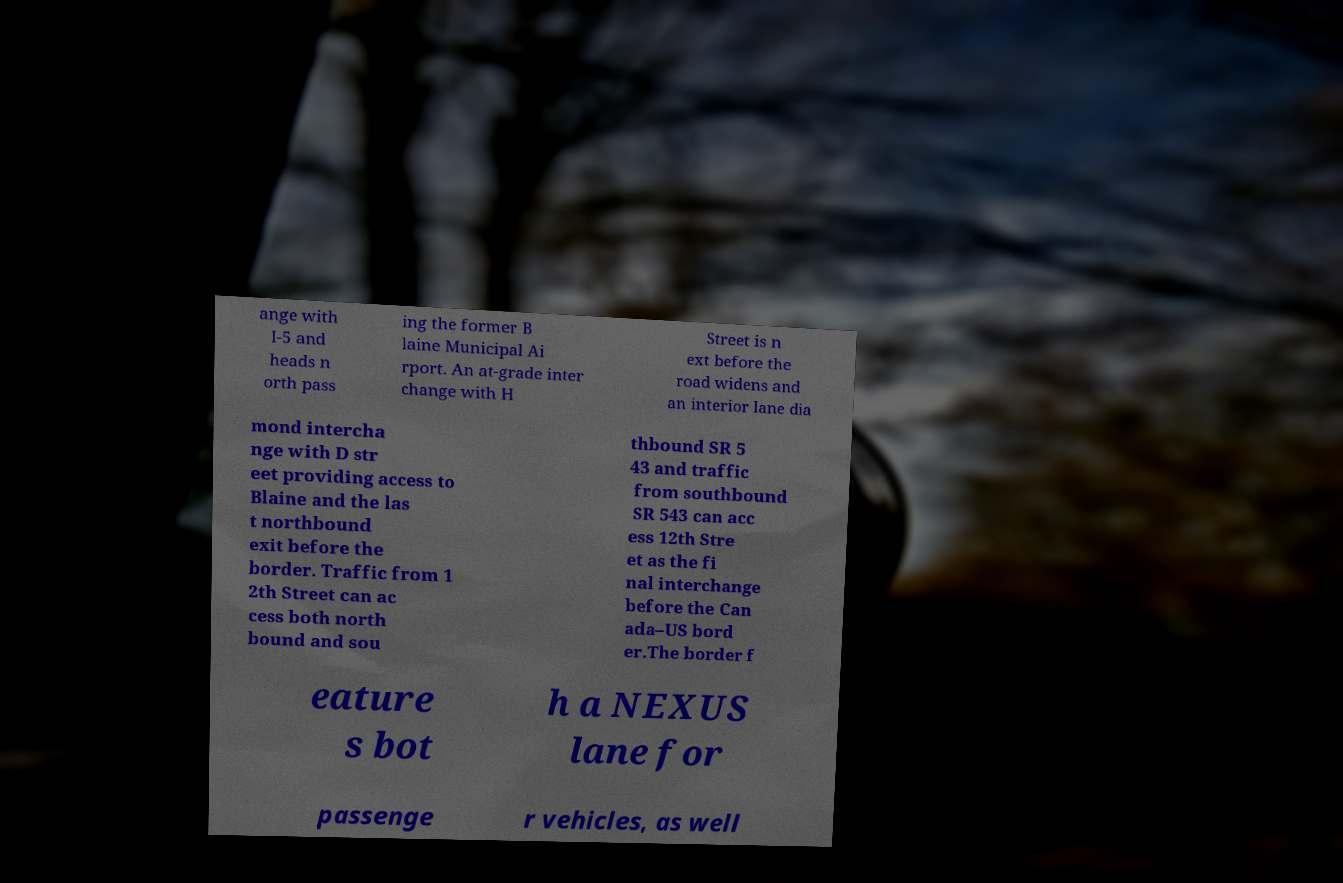Can you read and provide the text displayed in the image?This photo seems to have some interesting text. Can you extract and type it out for me? ange with I-5 and heads n orth pass ing the former B laine Municipal Ai rport. An at-grade inter change with H Street is n ext before the road widens and an interior lane dia mond intercha nge with D str eet providing access to Blaine and the las t northbound exit before the border. Traffic from 1 2th Street can ac cess both north bound and sou thbound SR 5 43 and traffic from southbound SR 543 can acc ess 12th Stre et as the fi nal interchange before the Can ada–US bord er.The border f eature s bot h a NEXUS lane for passenge r vehicles, as well 